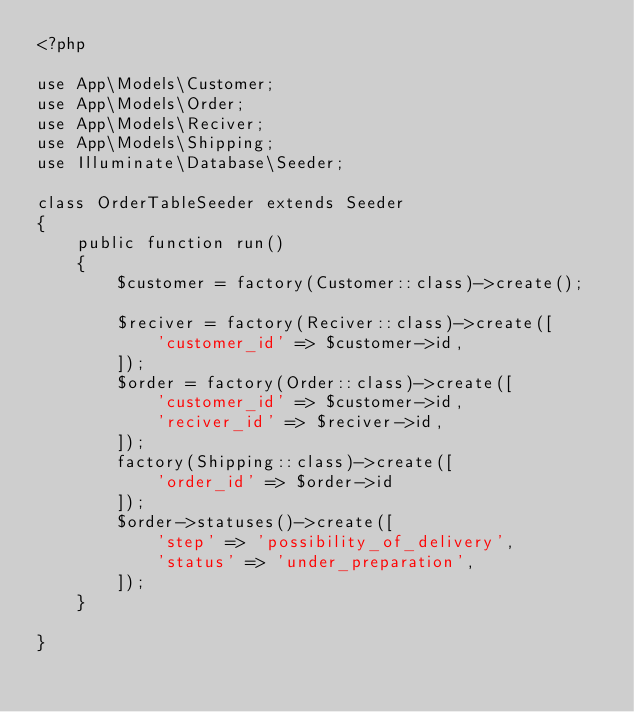Convert code to text. <code><loc_0><loc_0><loc_500><loc_500><_PHP_><?php

use App\Models\Customer;
use App\Models\Order;
use App\Models\Reciver;
use App\Models\Shipping;
use Illuminate\Database\Seeder;

class OrderTableSeeder extends Seeder
{
    public function run()
    {
        $customer = factory(Customer::class)->create();

        $reciver = factory(Reciver::class)->create([
            'customer_id' => $customer->id,
        ]);
        $order = factory(Order::class)->create([
            'customer_id' => $customer->id,
            'reciver_id' => $reciver->id,
        ]);
        factory(Shipping::class)->create([
            'order_id' => $order->id
        ]);
        $order->statuses()->create([
            'step' => 'possibility_of_delivery',
            'status' => 'under_preparation',
        ]);
    }

}
</code> 